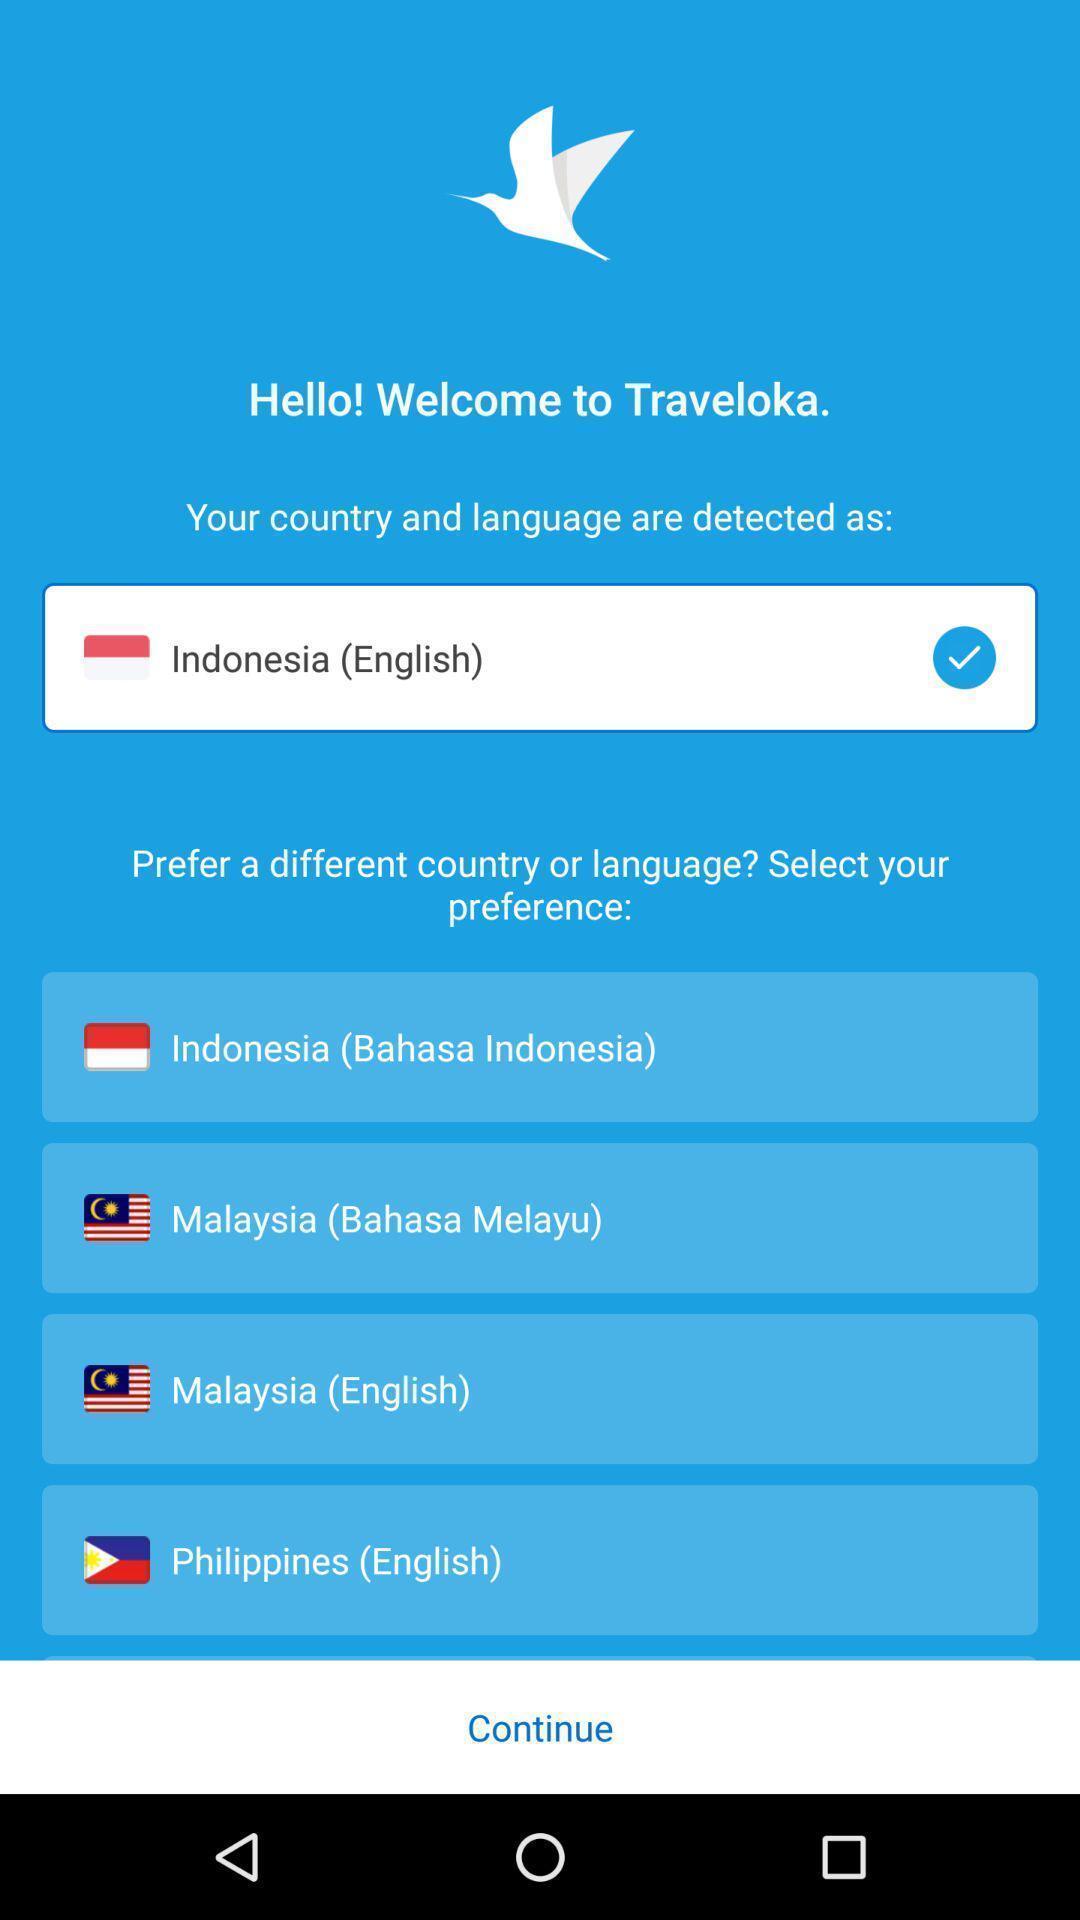Explain the elements present in this screenshot. Welcome page. 